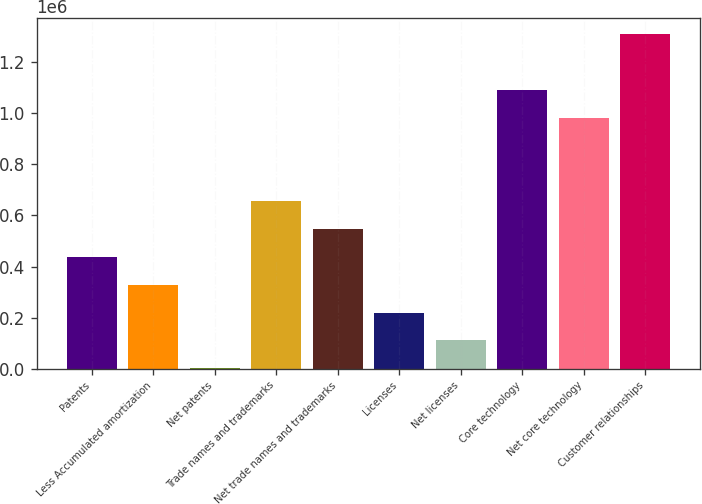Convert chart to OTSL. <chart><loc_0><loc_0><loc_500><loc_500><bar_chart><fcel>Patents<fcel>Less Accumulated amortization<fcel>Net patents<fcel>Trade names and trademarks<fcel>Net trade names and trademarks<fcel>Licenses<fcel>Net licenses<fcel>Core technology<fcel>Net core technology<fcel>Customer relationships<nl><fcel>437408<fcel>328374<fcel>1274<fcel>655475<fcel>546442<fcel>219341<fcel>110308<fcel>1.09161e+06<fcel>982576<fcel>1.30968e+06<nl></chart> 